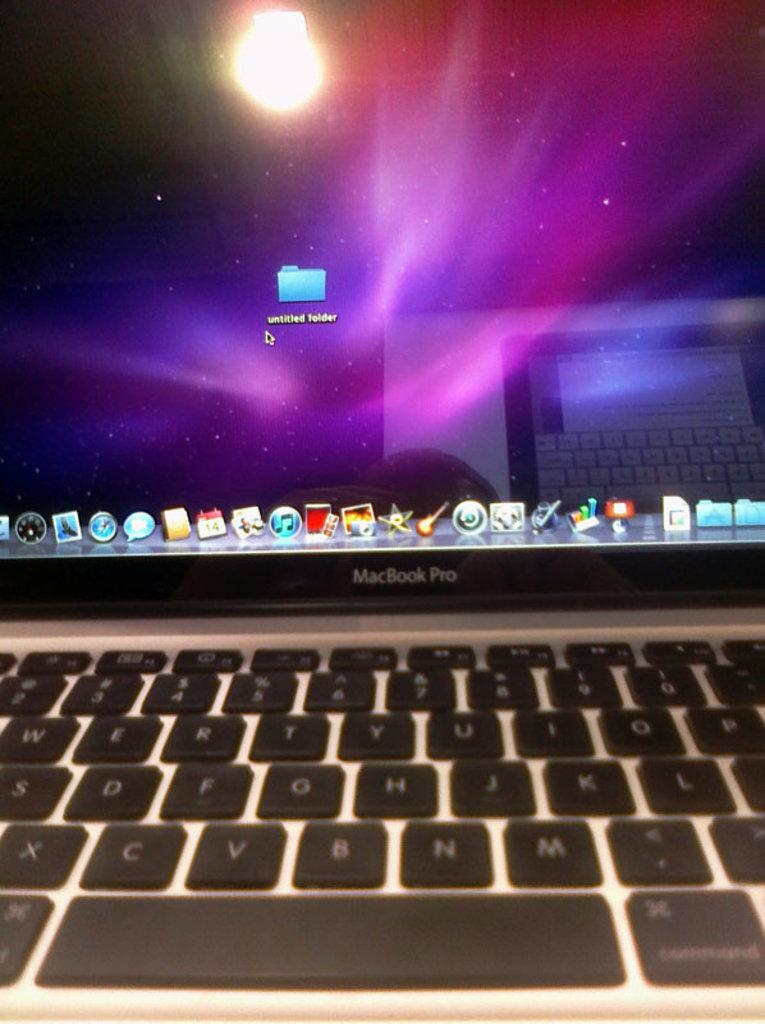<image>
Relay a brief, clear account of the picture shown. A MacBook Pro with an untitled folder in next to the mouse arrow. 